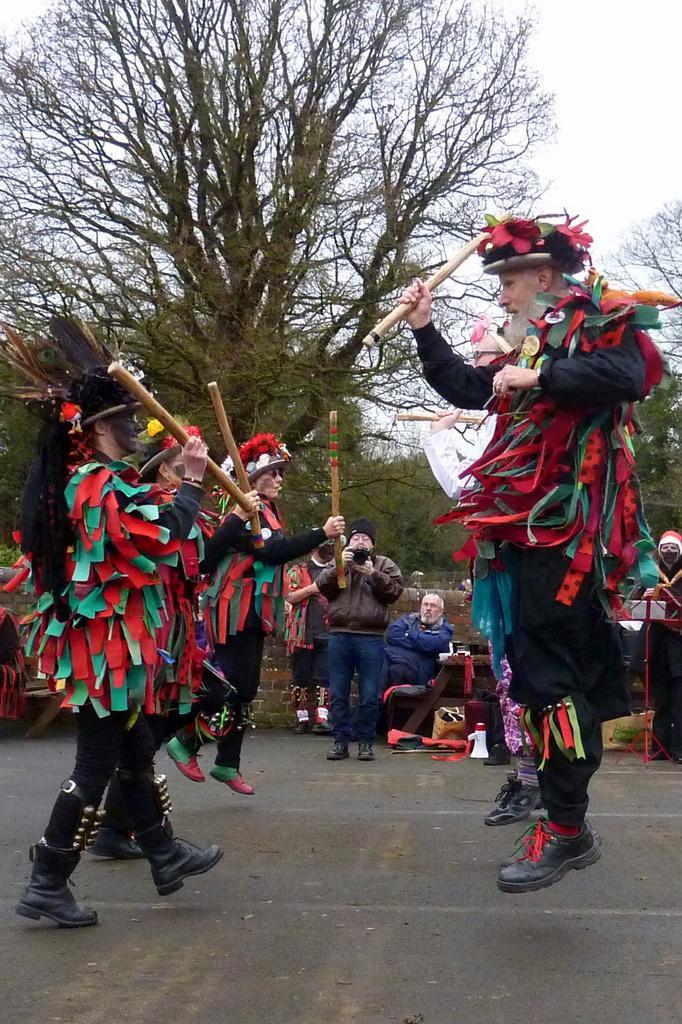Describe this image in one or two sentences. In this picture, we see the people who are wearing the costumes are holding the sticks in their hands and they are performing. At the bottom, we see the road. In the middle, we see a man is standing and he is clicking photos with the camera. Behind him, we see a man is sitting on the chair and a woman is standing. Behind them, we see a wall. There are trees in the background. At the top, we see the sky. 